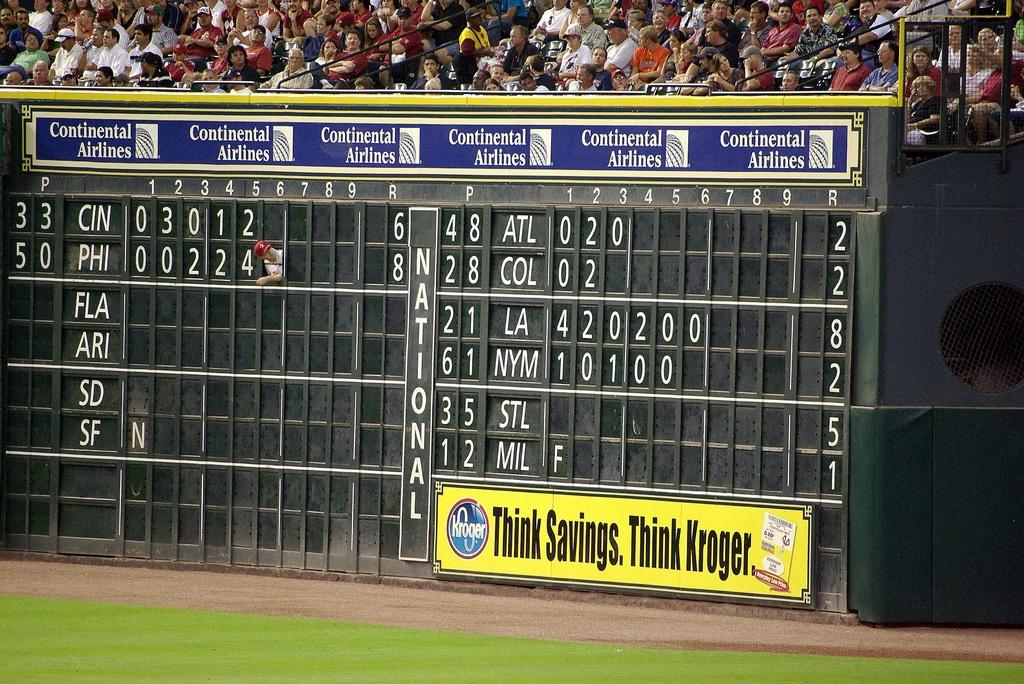<image>
Summarize the visual content of the image. A scoreboard at a sports venue that is sponsored by Kroger. 